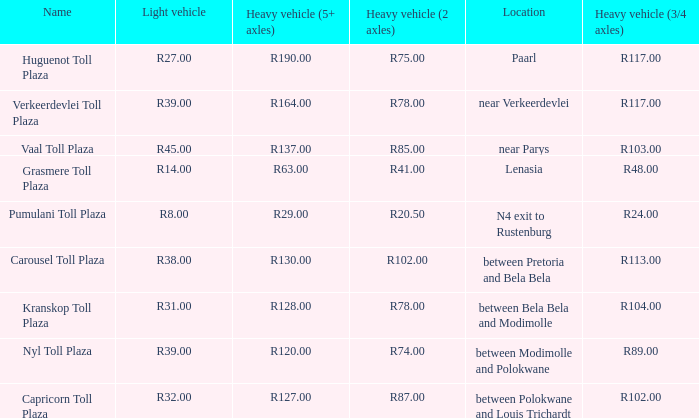What is the toll for light vehicles at the plaza where the toll for heavy vehicles with 2 axles is r87.00? R32.00. 